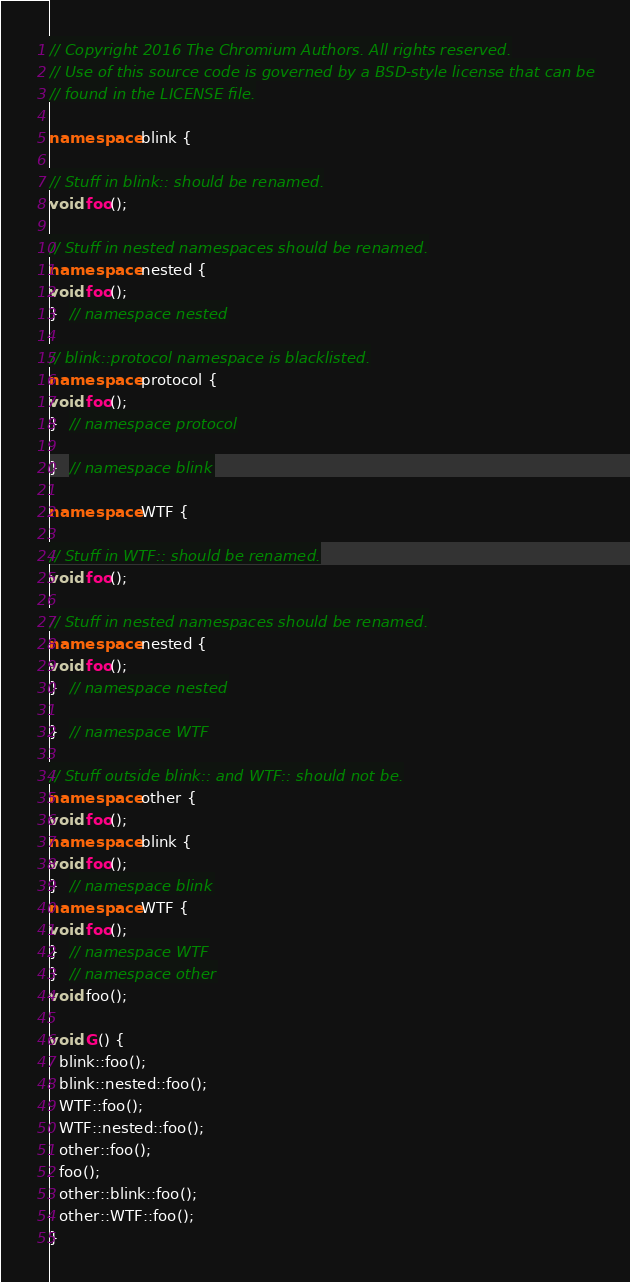<code> <loc_0><loc_0><loc_500><loc_500><_C++_>// Copyright 2016 The Chromium Authors. All rights reserved.
// Use of this source code is governed by a BSD-style license that can be
// found in the LICENSE file.

namespace blink {

// Stuff in blink:: should be renamed.
void foo();

// Stuff in nested namespaces should be renamed.
namespace nested {
void foo();
}  // namespace nested

// blink::protocol namespace is blacklisted.
namespace protocol {
void foo();
}  // namespace protocol

}  // namespace blink

namespace WTF {

// Stuff in WTF:: should be renamed.
void foo();

// Stuff in nested namespaces should be renamed.
namespace nested {
void foo();
}  // namespace nested

}  // namespace WTF

// Stuff outside blink:: and WTF:: should not be.
namespace other {
void foo();
namespace blink {
void foo();
}  // namespace blink
namespace WTF {
void foo();
}  // namespace WTF
}  // namespace other
void foo();

void G() {
  blink::foo();
  blink::nested::foo();
  WTF::foo();
  WTF::nested::foo();
  other::foo();
  foo();
  other::blink::foo();
  other::WTF::foo();
}
</code> 